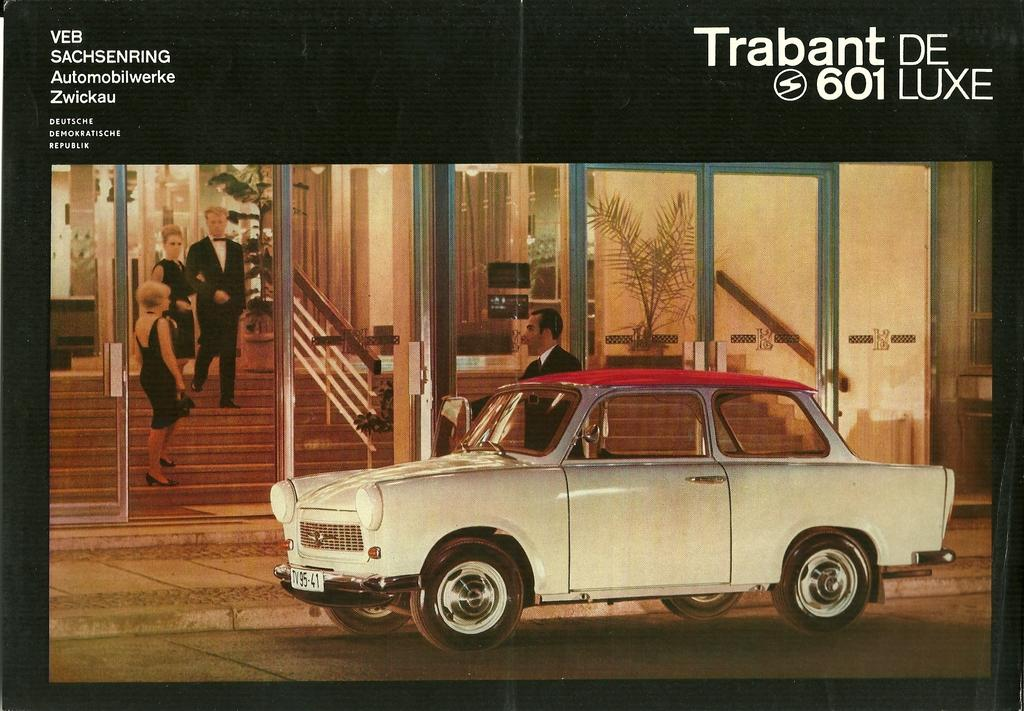What is the main object in the image? There is a car in the image. How many people are in the image? There are two men and two women in the image. What are the people wearing? The people are wearing clothes. What architectural features can be seen in the image? There are stairs, glass doors, and a wall in the image. What is present near the wall? There is a plant pot in the image. How does the car move around in the image? The car does not move around in the image; it is stationary. What type of hot beverage is being served in the image? There is no hot beverage present in the image. 